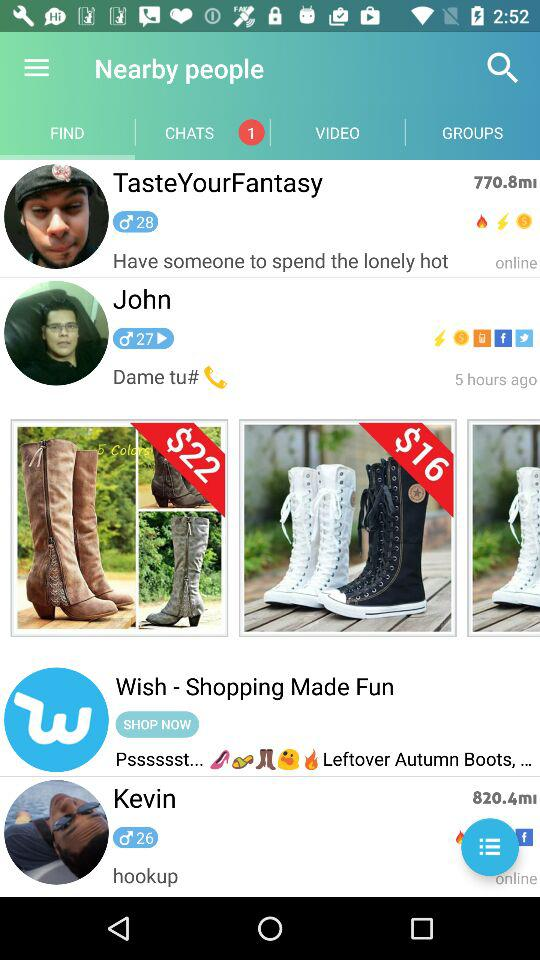What's the departure date?
When the provided information is insufficient, respond with <no answer>. <no answer> 